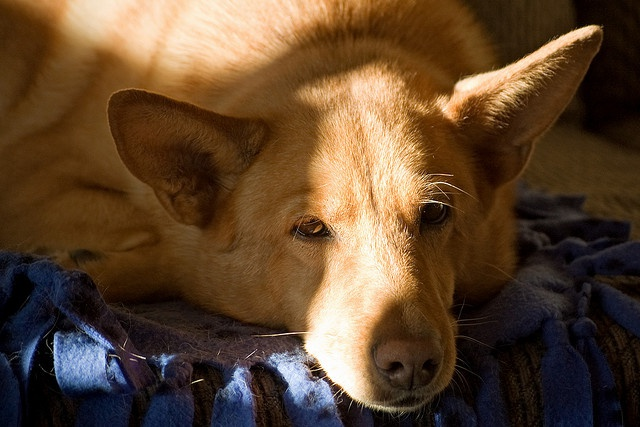Describe the objects in this image and their specific colors. I can see a dog in maroon, black, and tan tones in this image. 